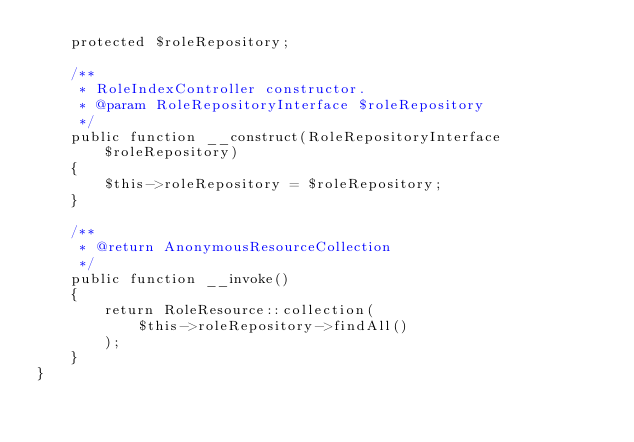Convert code to text. <code><loc_0><loc_0><loc_500><loc_500><_PHP_>    protected $roleRepository;

    /**
     * RoleIndexController constructor.
     * @param RoleRepositoryInterface $roleRepository
     */
    public function __construct(RoleRepositoryInterface $roleRepository)
    {
        $this->roleRepository = $roleRepository;
    }

    /**
     * @return AnonymousResourceCollection
     */
    public function __invoke()
    {
        return RoleResource::collection(
            $this->roleRepository->findAll()
        );
    }
}
</code> 